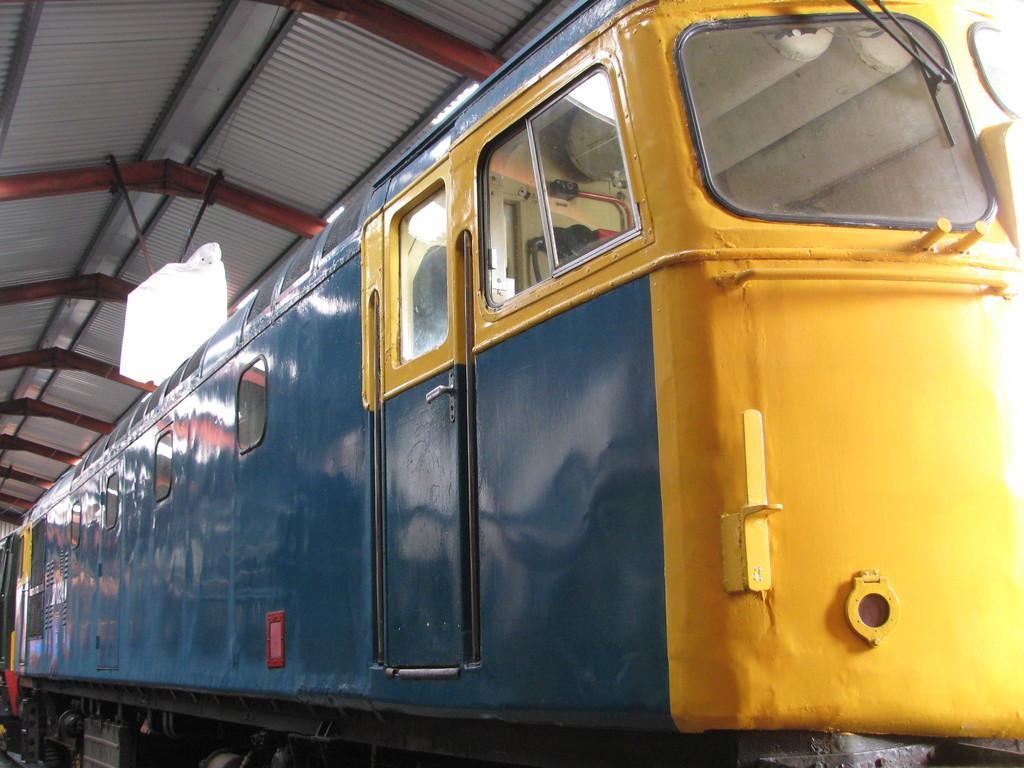In one or two sentences, can you explain what this image depicts? In this image I can see a yellow and a blue train. There is a light at the top and a tin roof. 